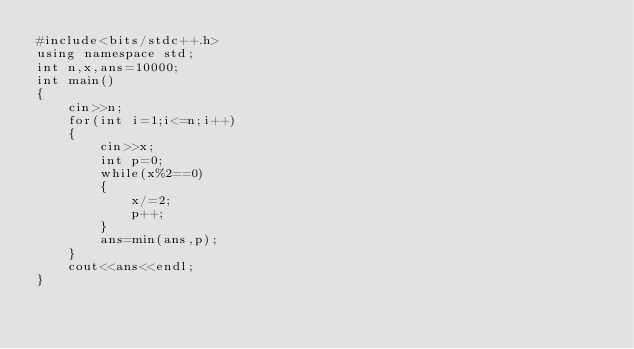<code> <loc_0><loc_0><loc_500><loc_500><_C++_>#include<bits/stdc++.h>
using namespace std;
int n,x,ans=10000;
int main()
{
    cin>>n;
    for(int i=1;i<=n;i++)
    {
        cin>>x;
        int p=0;
        while(x%2==0)
        {
            x/=2;
            p++;
        }
        ans=min(ans,p);
    }
    cout<<ans<<endl;
}</code> 